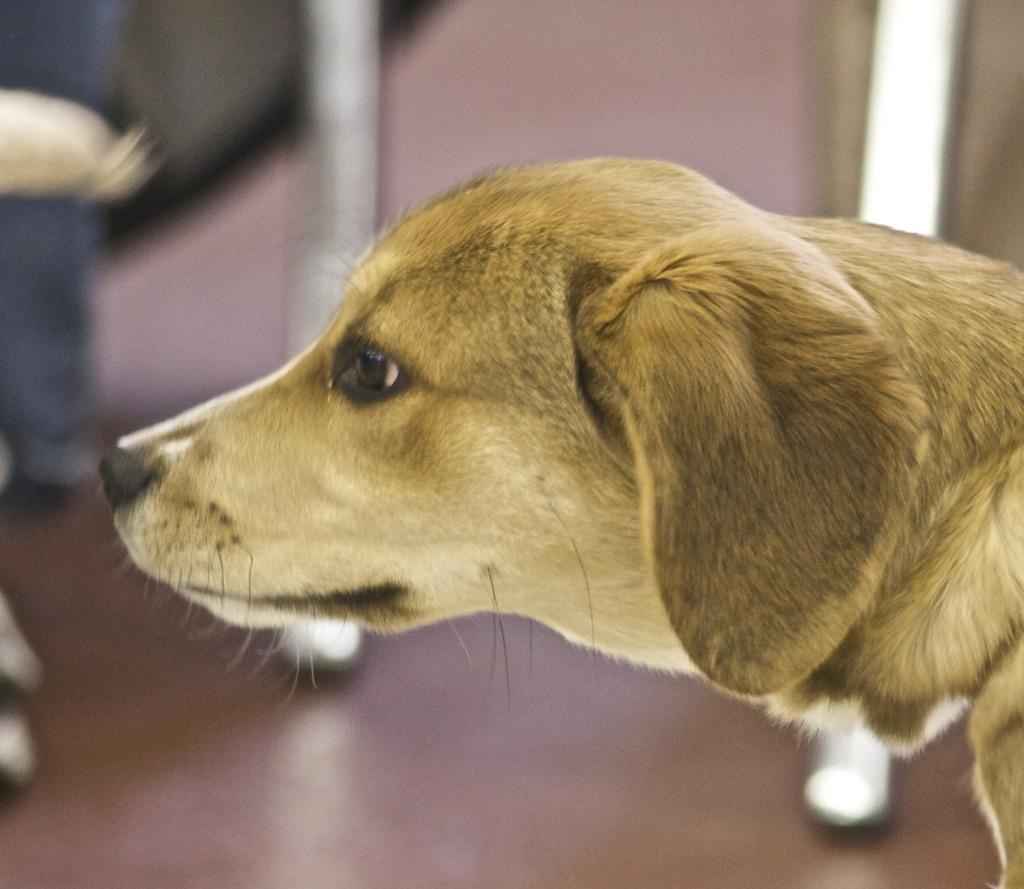What is the main subject of the image? The main subject of the image is a dog. Can you describe the background of the image? The background of the image is blurred. What type of turkey is being taught by the mother in the image? There is no turkey or mother present in the image; it features a dog as the main subject. 